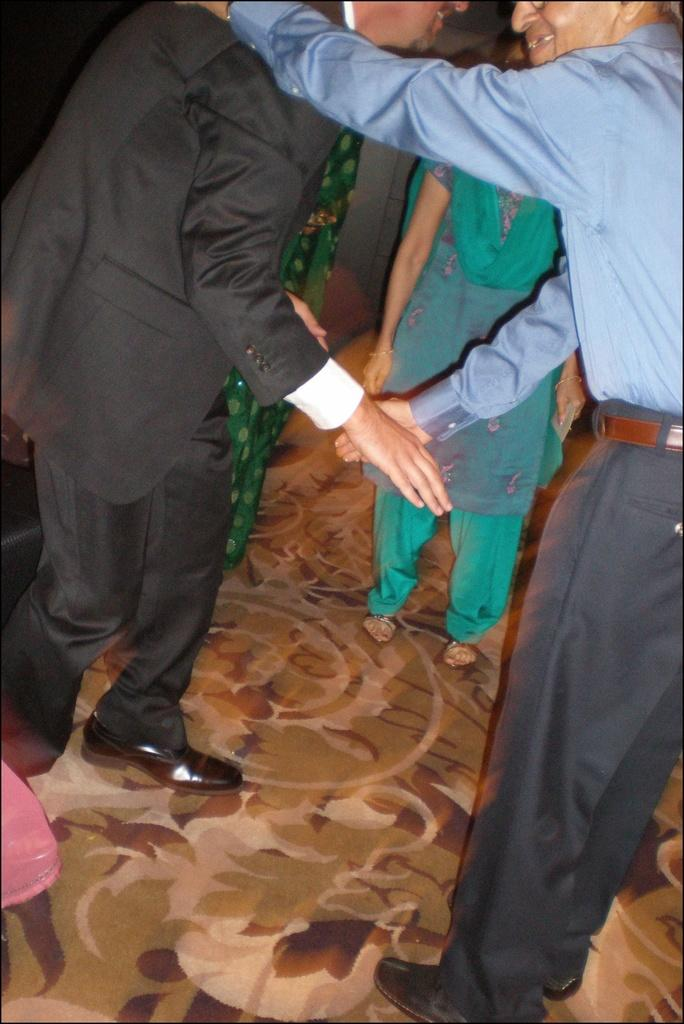What is happening in the image involving the people? Two men are shaking hands in the image. How many people are present in the image? There are people standing in the image, but the exact number is not specified. Are the two men kissing in the image? No, the two men are shaking hands, not kissing, in the image. 